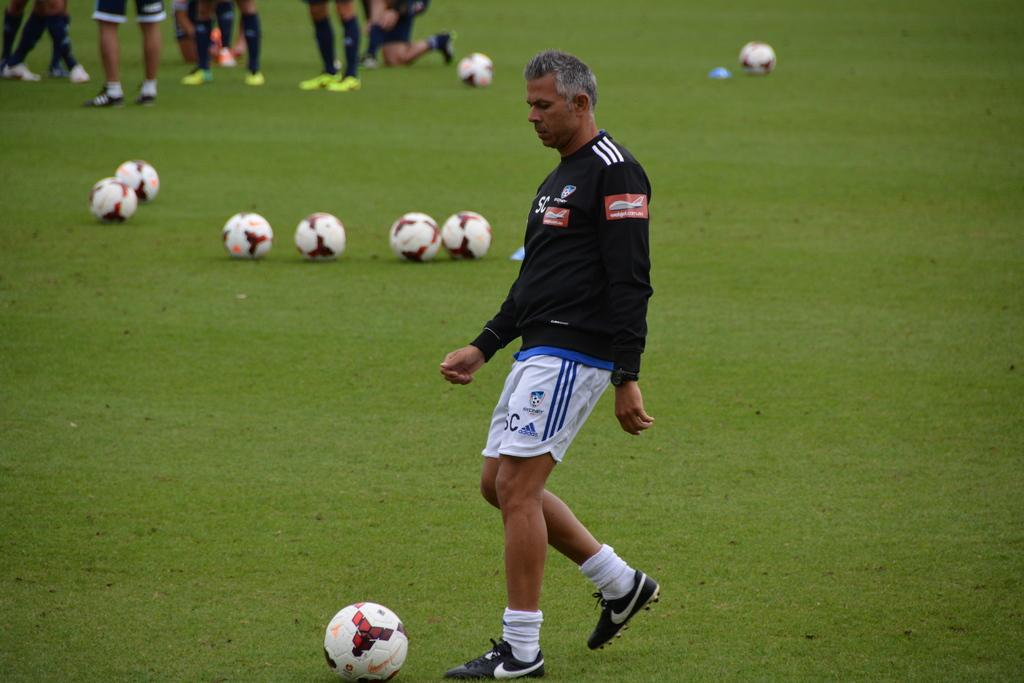What is the main surface visible in the image? There is a ground in the image. What objects are on the ground? There are balls on the ground. Can you describe the person in the image? There is a person in the image. What part of other people can be seen in the image? Few person's legs are visible at the top of the image. What type of thread is being used to protest in the image? There is no protest or thread present in the image. 